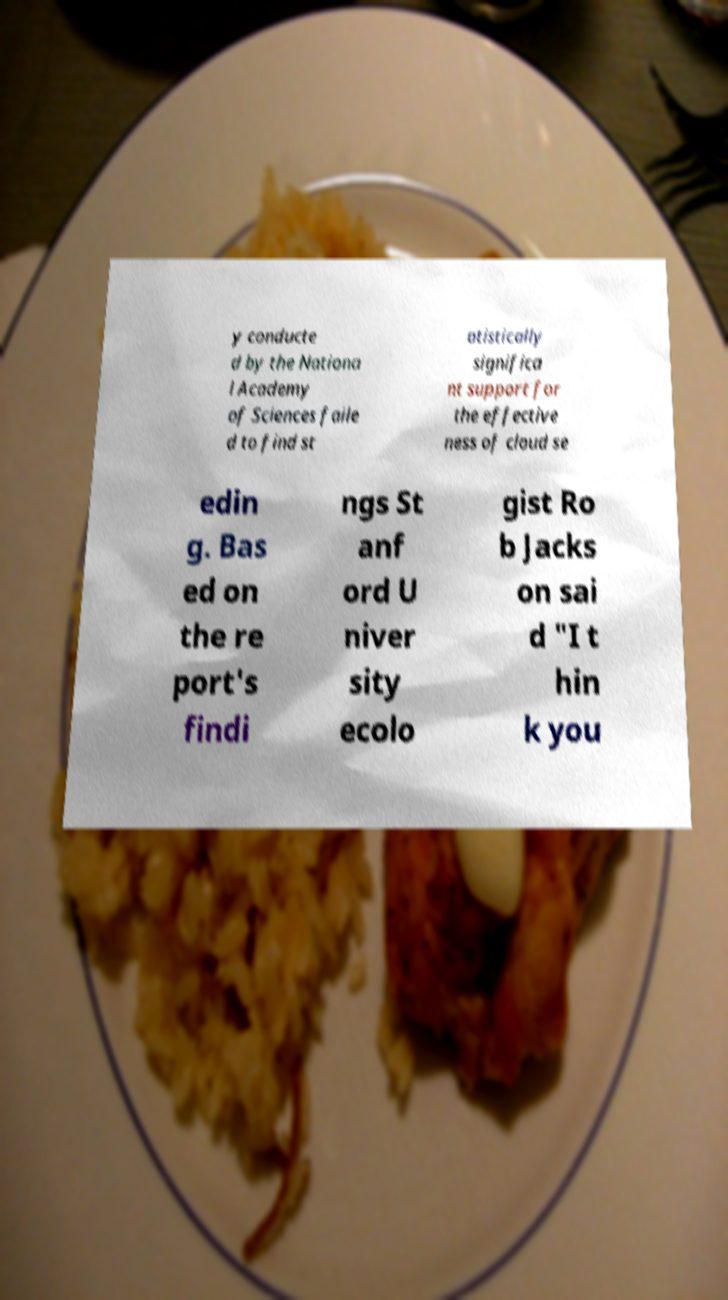Can you accurately transcribe the text from the provided image for me? y conducte d by the Nationa l Academy of Sciences faile d to find st atistically significa nt support for the effective ness of cloud se edin g. Bas ed on the re port's findi ngs St anf ord U niver sity ecolo gist Ro b Jacks on sai d "I t hin k you 